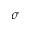Convert formula to latex. <formula><loc_0><loc_0><loc_500><loc_500>\sigma</formula> 